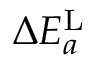Convert formula to latex. <formula><loc_0><loc_0><loc_500><loc_500>\Delta E _ { a } ^ { L }</formula> 